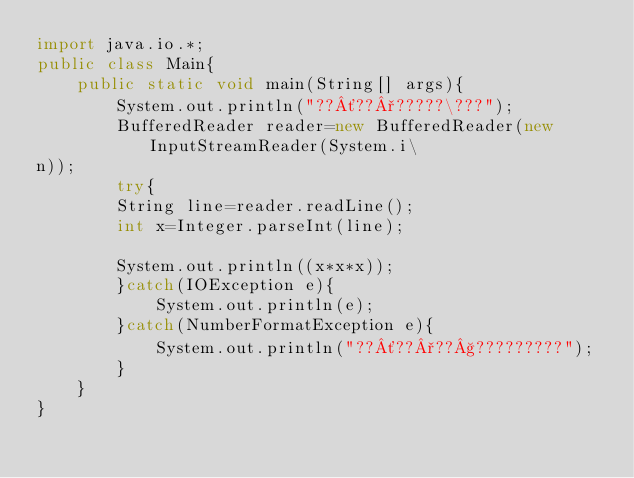Convert code to text. <code><loc_0><loc_0><loc_500><loc_500><_Java_>import java.io.*;
public class Main{
    public static void main(String[] args){
        System.out.println("??´??°?????\???");
        BufferedReader reader=new BufferedReader(new InputStreamReader(System.i\
n));
        try{
        String line=reader.readLine();
        int x=Integer.parseInt(line);

        System.out.println((x*x*x));
        }catch(IOException e){
            System.out.println(e);
        }catch(NumberFormatException e){
            System.out.println("??´??°??§?????????");
        }
    }
}</code> 